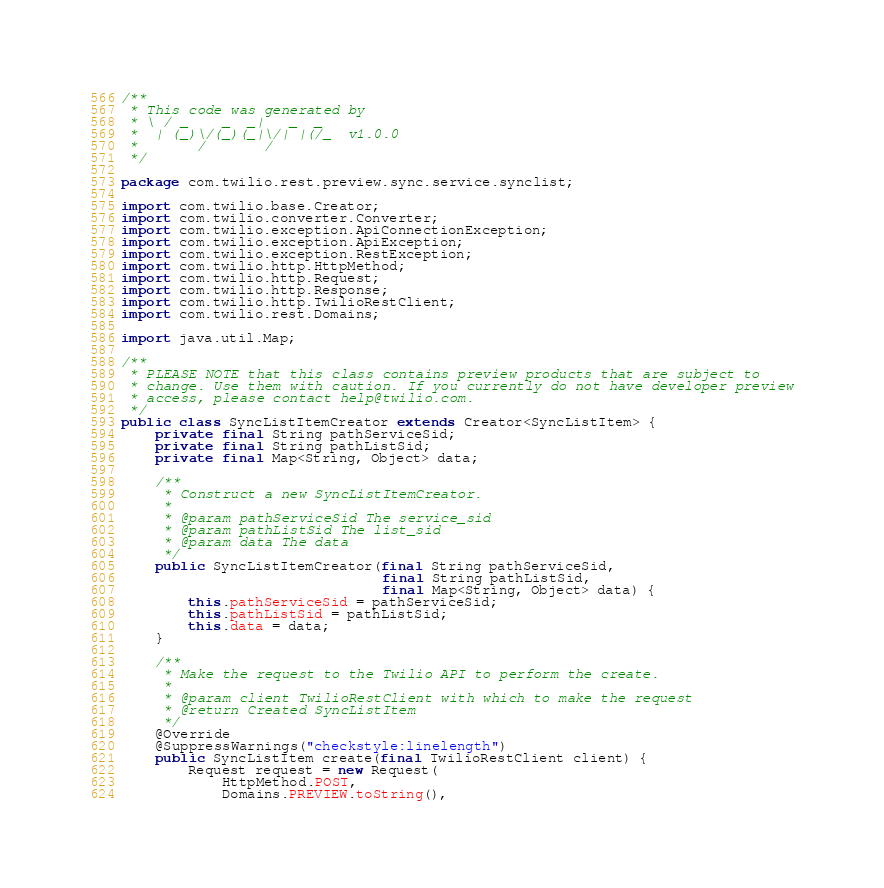<code> <loc_0><loc_0><loc_500><loc_500><_Java_>/**
 * This code was generated by
 * \ / _    _  _|   _  _
 *  | (_)\/(_)(_|\/| |(/_  v1.0.0
 *       /       /
 */

package com.twilio.rest.preview.sync.service.synclist;

import com.twilio.base.Creator;
import com.twilio.converter.Converter;
import com.twilio.exception.ApiConnectionException;
import com.twilio.exception.ApiException;
import com.twilio.exception.RestException;
import com.twilio.http.HttpMethod;
import com.twilio.http.Request;
import com.twilio.http.Response;
import com.twilio.http.TwilioRestClient;
import com.twilio.rest.Domains;

import java.util.Map;

/**
 * PLEASE NOTE that this class contains preview products that are subject to
 * change. Use them with caution. If you currently do not have developer preview
 * access, please contact help@twilio.com.
 */
public class SyncListItemCreator extends Creator<SyncListItem> {
    private final String pathServiceSid;
    private final String pathListSid;
    private final Map<String, Object> data;

    /**
     * Construct a new SyncListItemCreator.
     *
     * @param pathServiceSid The service_sid
     * @param pathListSid The list_sid
     * @param data The data
     */
    public SyncListItemCreator(final String pathServiceSid,
                               final String pathListSid,
                               final Map<String, Object> data) {
        this.pathServiceSid = pathServiceSid;
        this.pathListSid = pathListSid;
        this.data = data;
    }

    /**
     * Make the request to the Twilio API to perform the create.
     *
     * @param client TwilioRestClient with which to make the request
     * @return Created SyncListItem
     */
    @Override
    @SuppressWarnings("checkstyle:linelength")
    public SyncListItem create(final TwilioRestClient client) {
        Request request = new Request(
            HttpMethod.POST,
            Domains.PREVIEW.toString(),</code> 